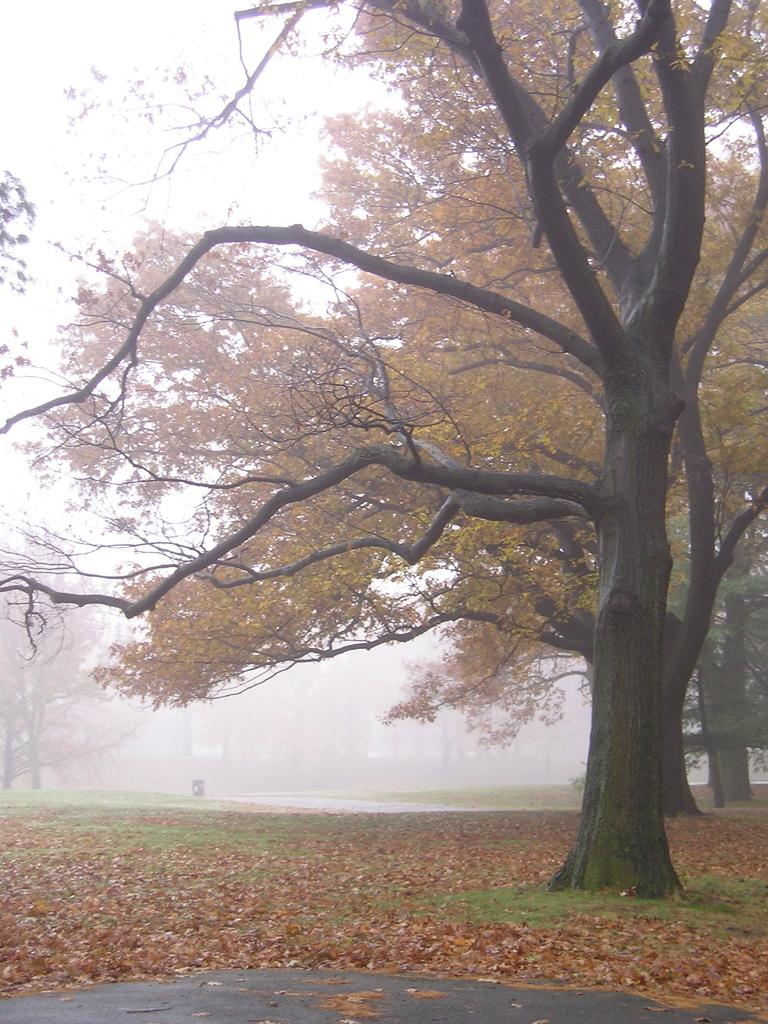What type of vegetation can be seen in the image? There are trees in the image. What is present on the ground in the image? There are dried leaves on the ground in the image. What type of cake is being served during the recess in the image? There is no recess or cake present in the image; it only features trees and dried leaves on the ground. 